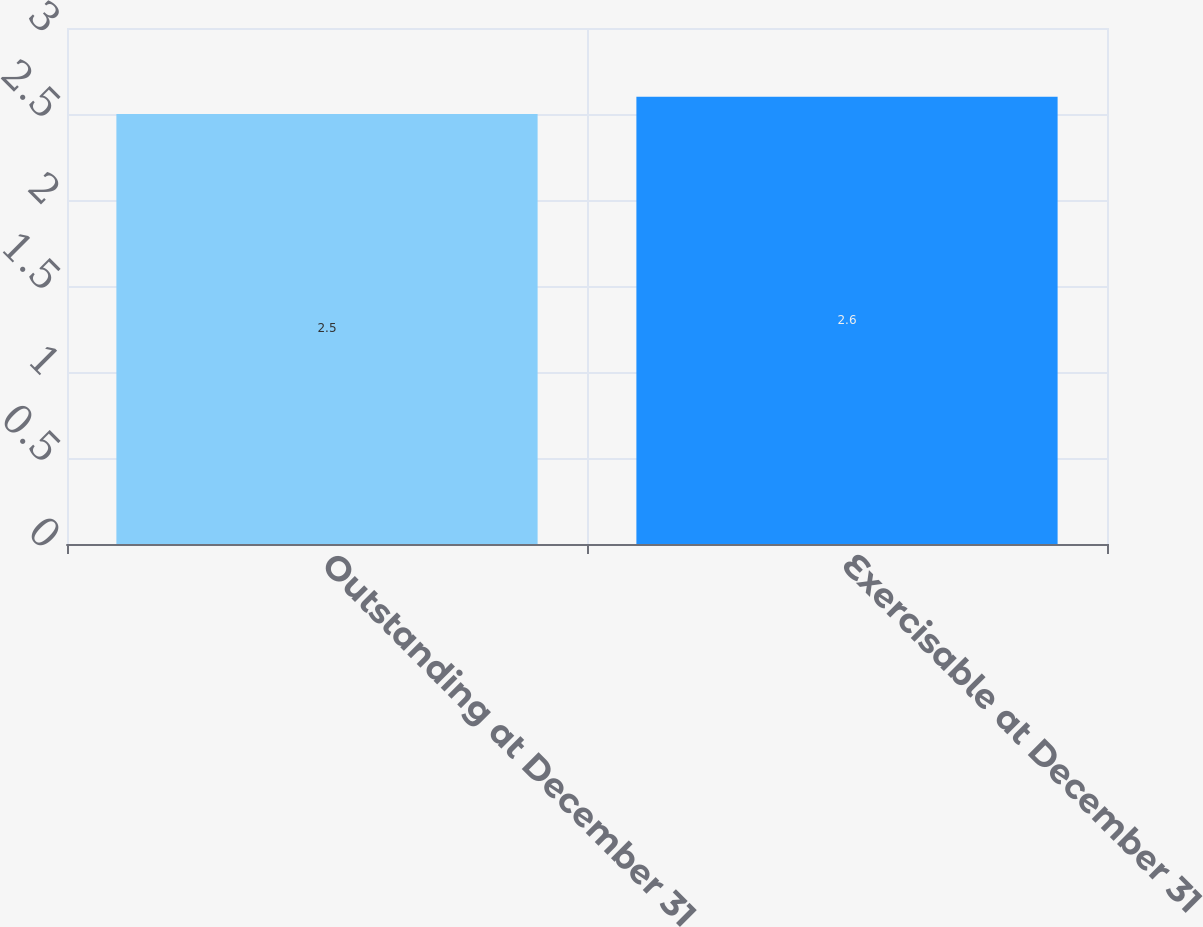Convert chart to OTSL. <chart><loc_0><loc_0><loc_500><loc_500><bar_chart><fcel>Outstanding at December 31<fcel>Exercisable at December 31<nl><fcel>2.5<fcel>2.6<nl></chart> 